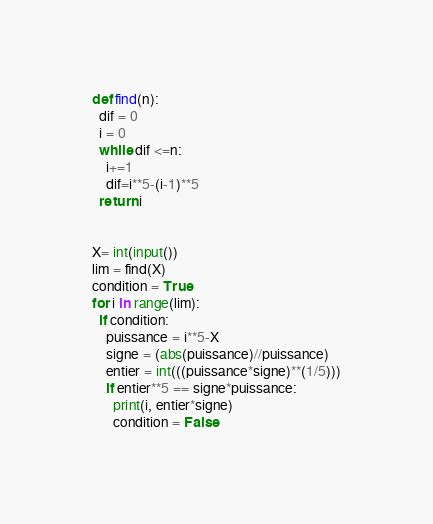Convert code to text. <code><loc_0><loc_0><loc_500><loc_500><_Python_>def find(n):
  dif = 0
  i = 0
  while dif <=n:
    i+=1
    dif=i**5-(i-1)**5
  return i


X= int(input())
lim = find(X)
condition = True
for i in range(lim):
  if condition:
    puissance = i**5-X
    signe = (abs(puissance)//puissance)
    entier = int(((puissance*signe)**(1/5)))
    if entier**5 == signe*puissance:
      print(i, entier*signe)
      condition = False
</code> 